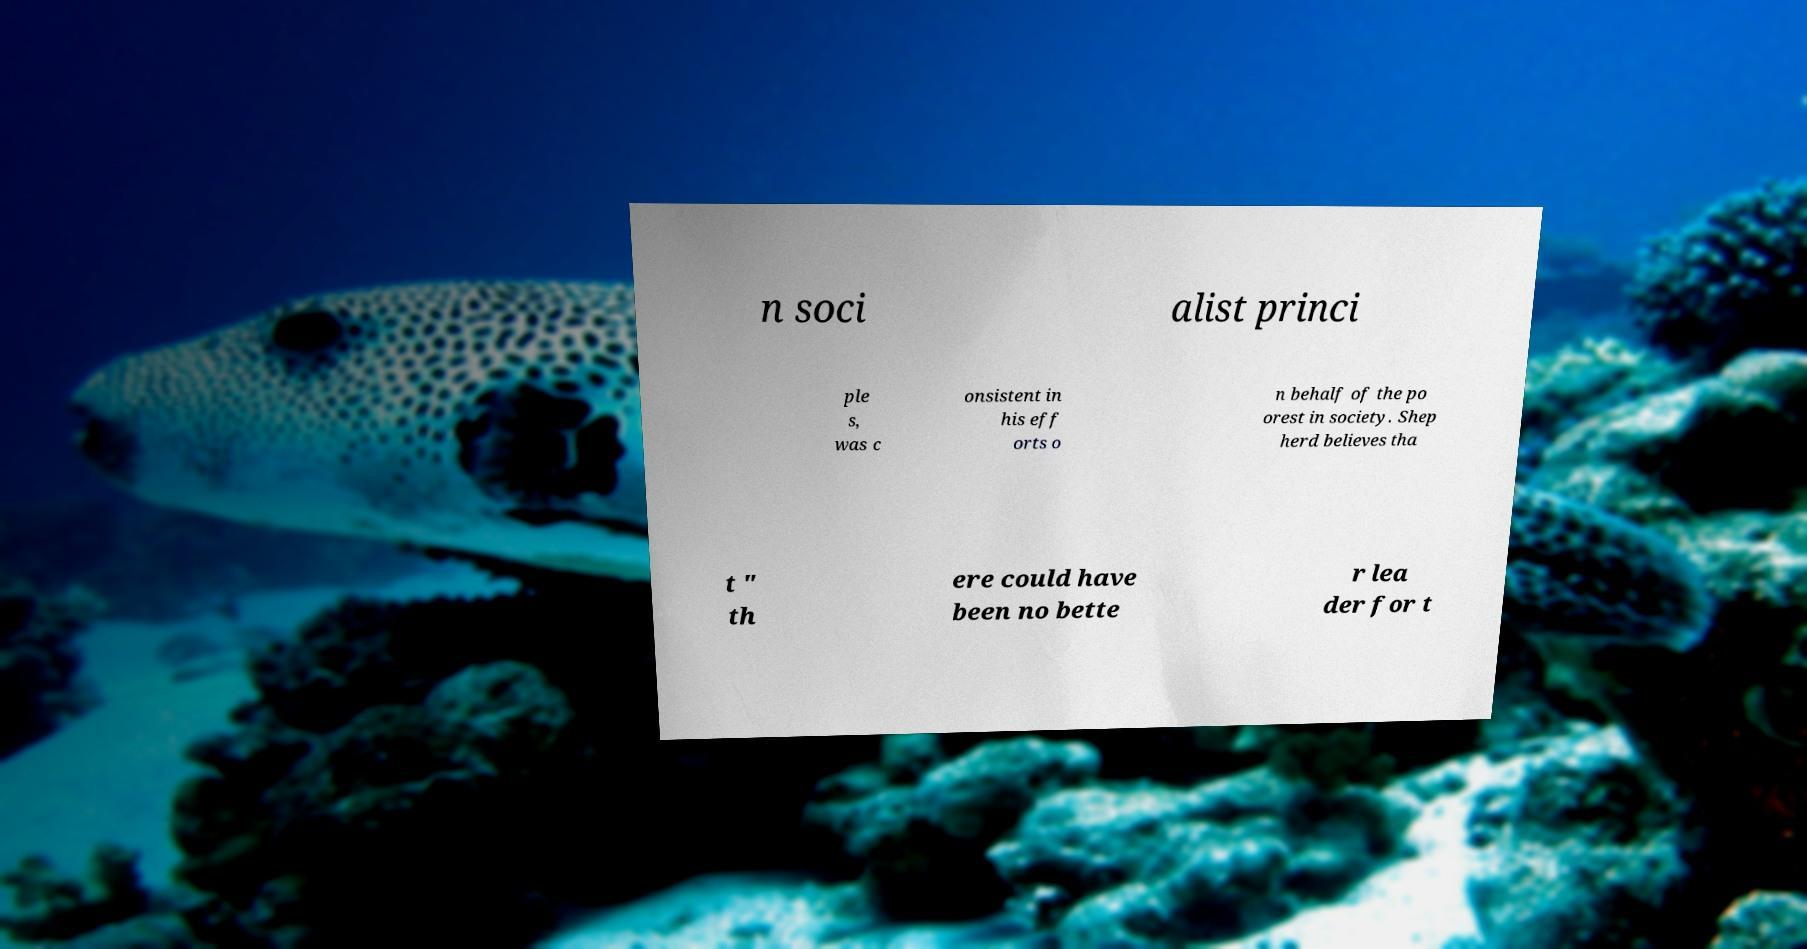There's text embedded in this image that I need extracted. Can you transcribe it verbatim? n soci alist princi ple s, was c onsistent in his eff orts o n behalf of the po orest in society. Shep herd believes tha t " th ere could have been no bette r lea der for t 